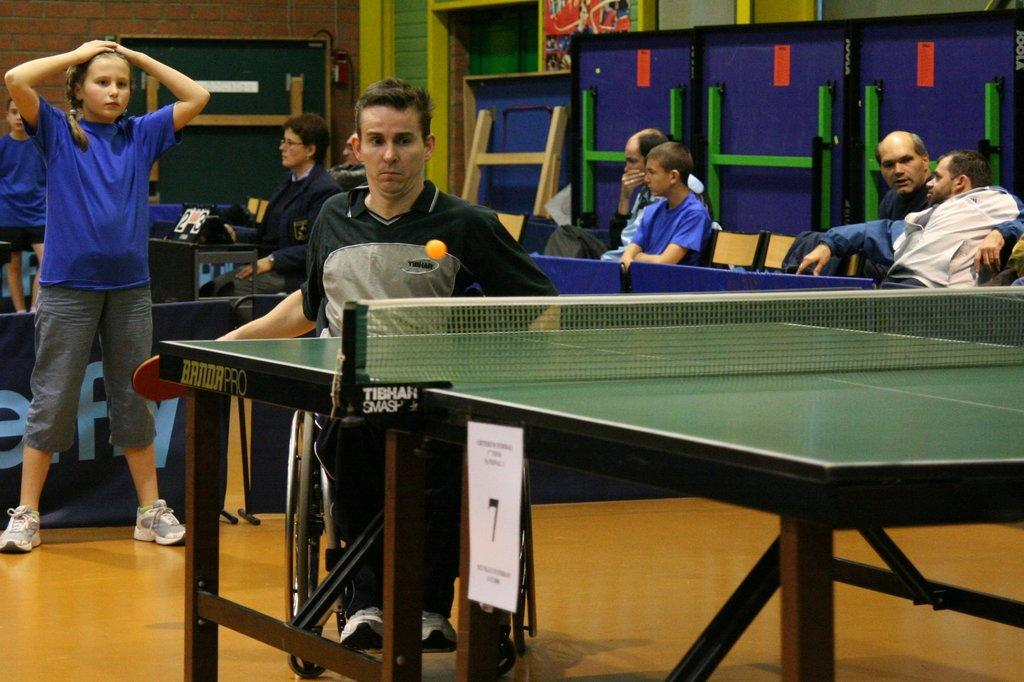What are the people in the image doing? There are people seated on chairs and a man playing table tennis in the image. Can you describe the man playing table tennis? The man playing table tennis is seated on a wheelchair in the image. Is there anyone else in the image besides the people seated on chairs? Yes, there is a woman standing on the man's back in the image. What type of quiver is the carpenter using to burst the balloons in the image? There is no carpenter, quiver, or balloons present in the image. 